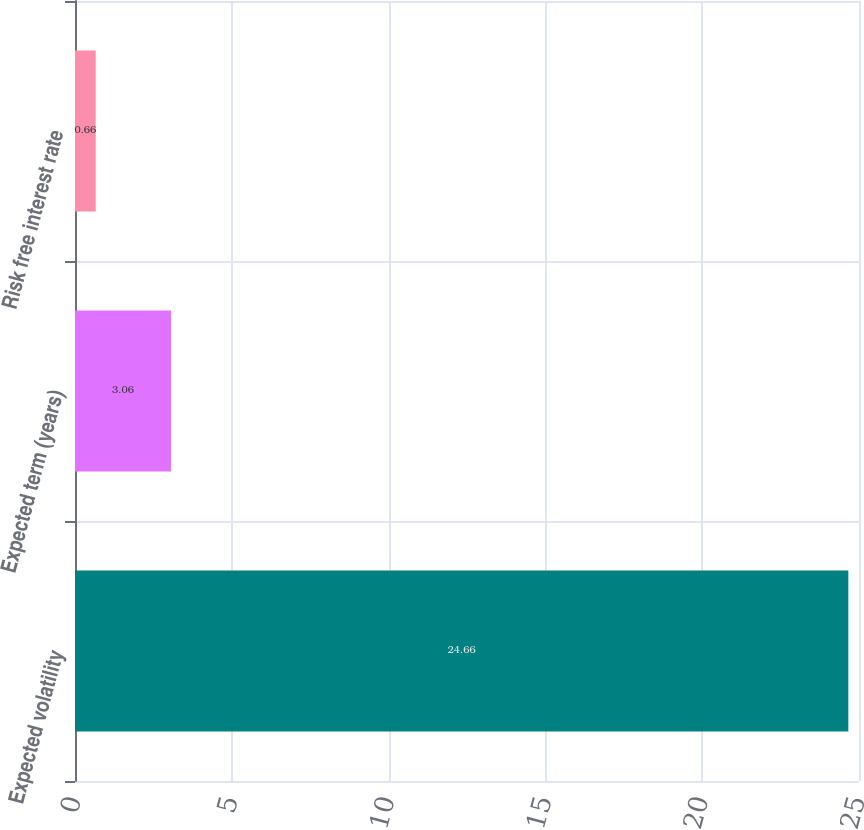Convert chart. <chart><loc_0><loc_0><loc_500><loc_500><bar_chart><fcel>Expected volatility<fcel>Expected term (years)<fcel>Risk free interest rate<nl><fcel>24.66<fcel>3.06<fcel>0.66<nl></chart> 